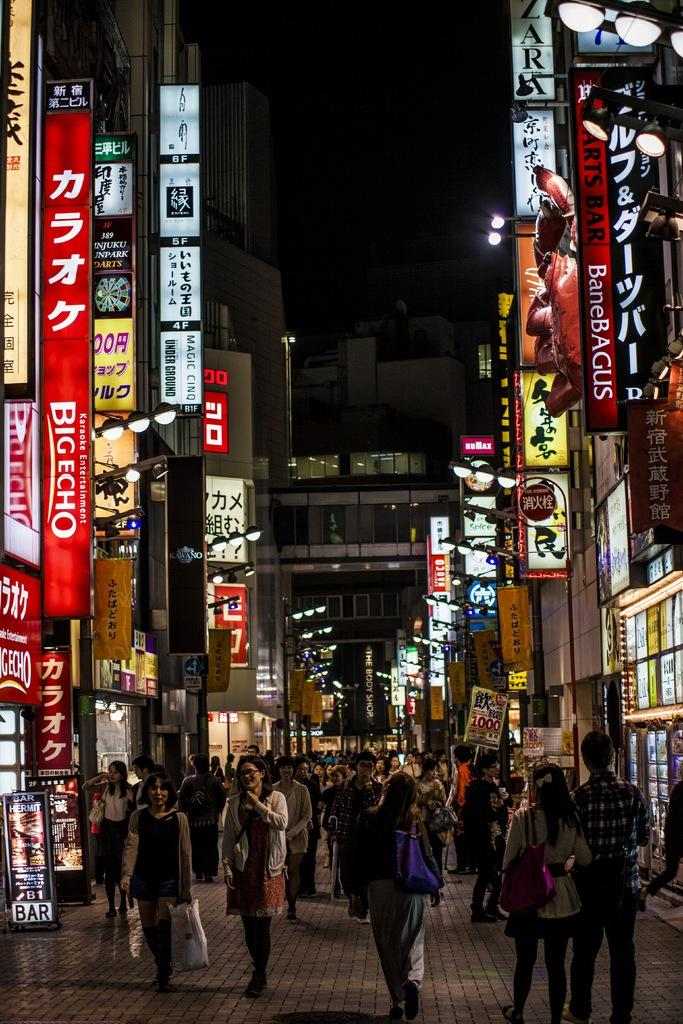<image>
Relay a brief, clear account of the picture shown. One of the places on this street is Big Echo karaoke. 